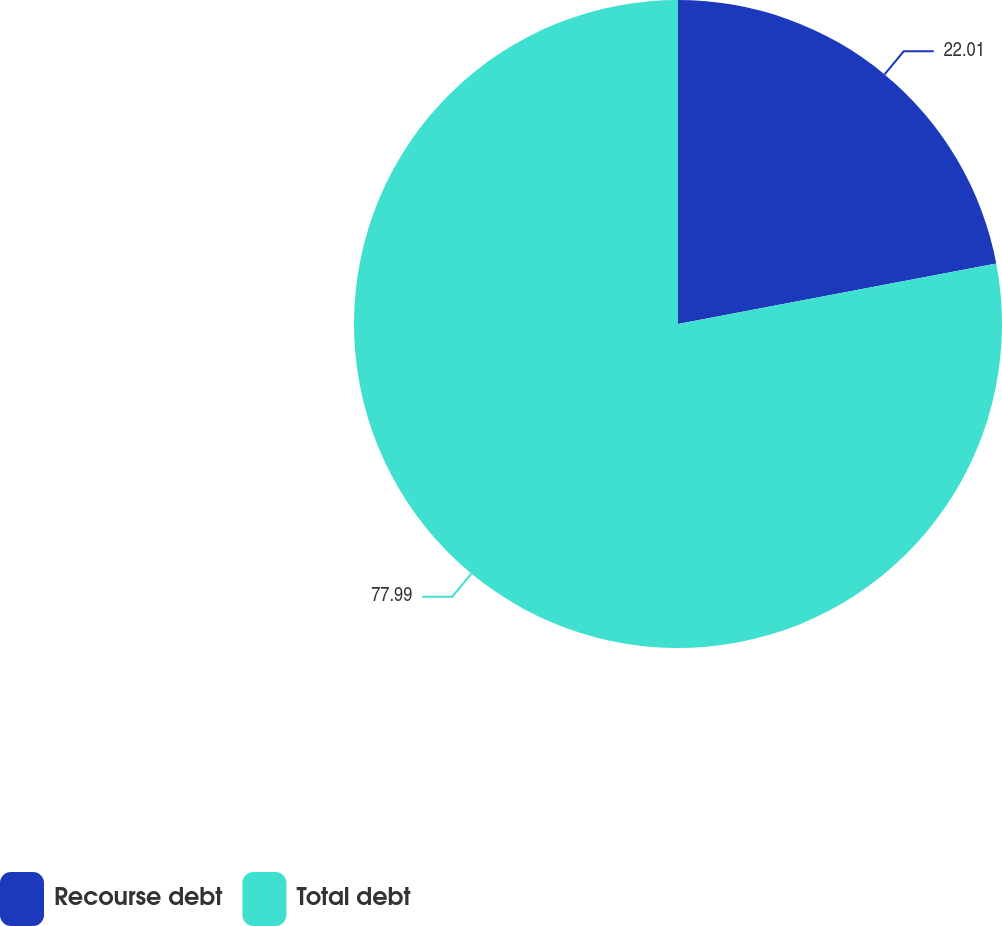Convert chart. <chart><loc_0><loc_0><loc_500><loc_500><pie_chart><fcel>Recourse debt<fcel>Total debt<nl><fcel>22.01%<fcel>77.99%<nl></chart> 